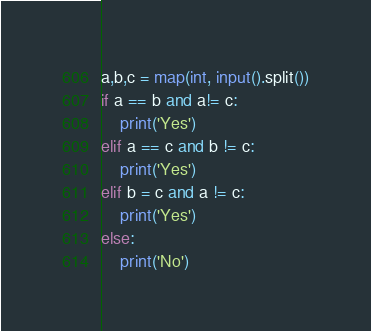<code> <loc_0><loc_0><loc_500><loc_500><_Python_>a,b,c = map(int, input().split())
if a == b and a!= c:
    print('Yes')
elif a == c and b != c:
    print('Yes')
elif b = c and a != c:
    print('Yes')
else:
    print('No')</code> 